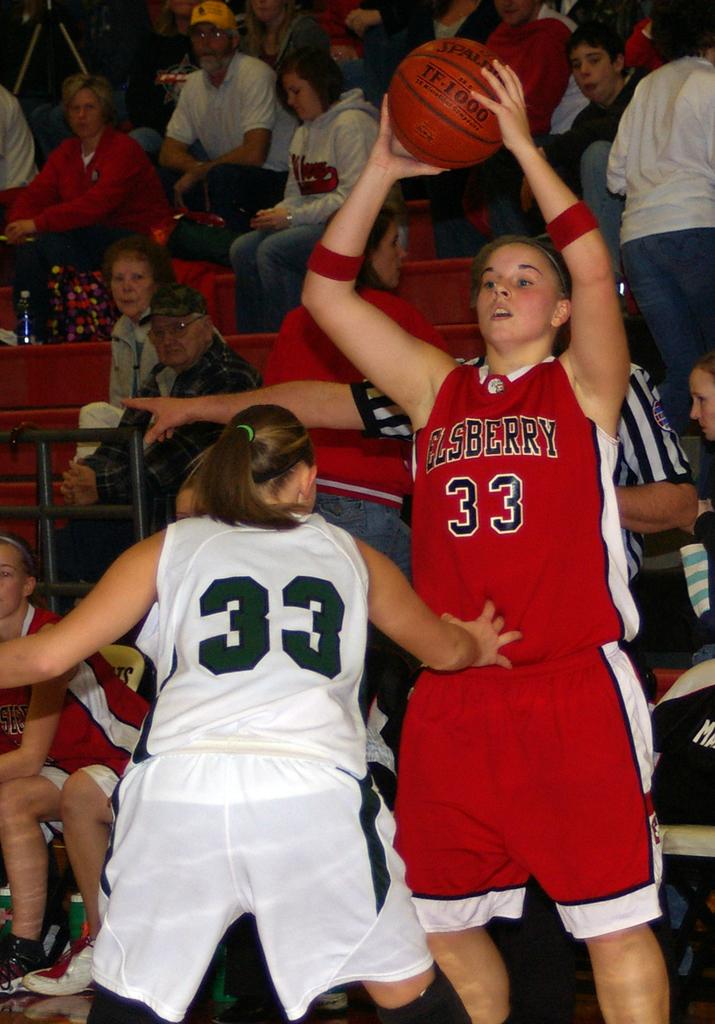What is the player in whites jersey number?
Provide a succinct answer. 33. 